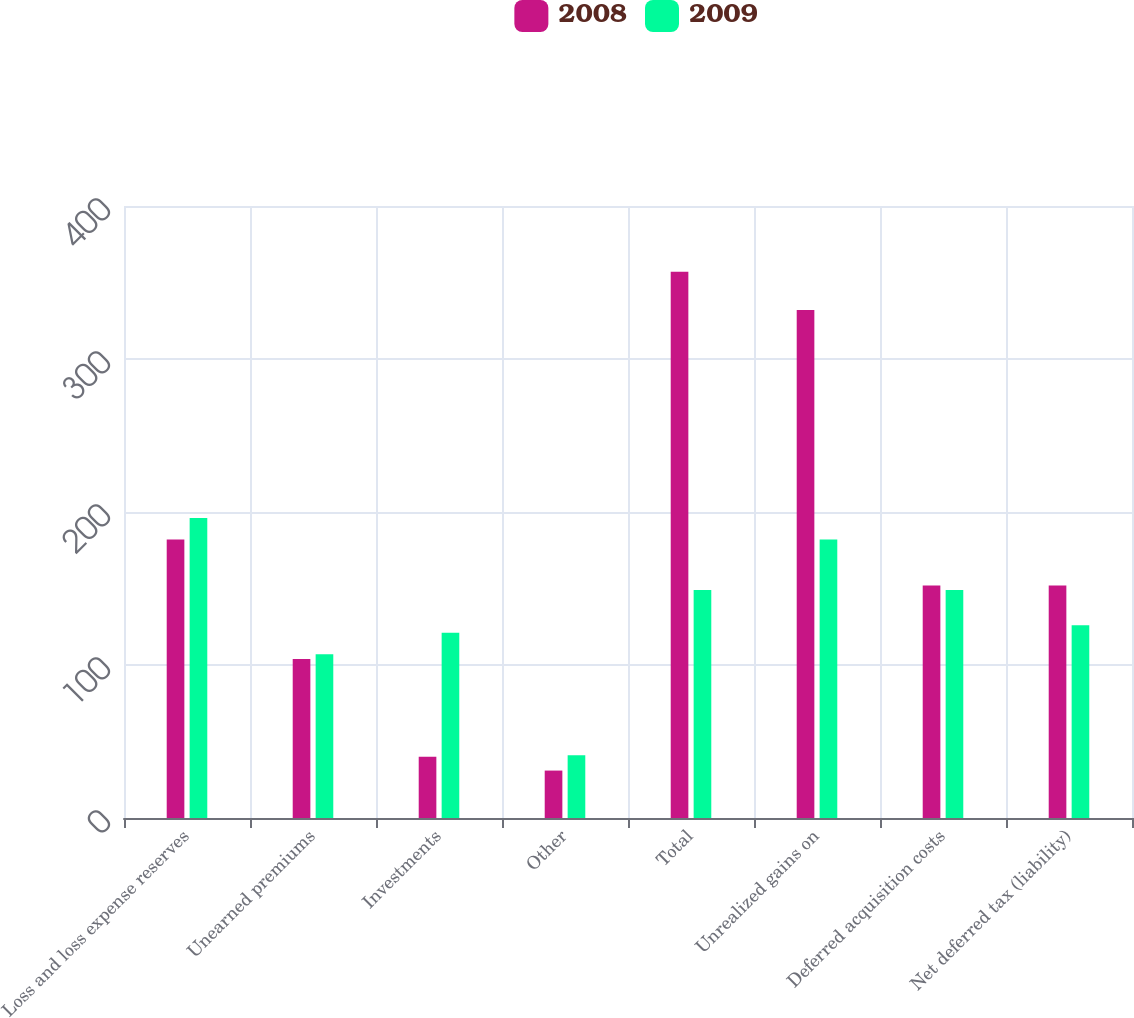Convert chart to OTSL. <chart><loc_0><loc_0><loc_500><loc_500><stacked_bar_chart><ecel><fcel>Loss and loss expense reserves<fcel>Unearned premiums<fcel>Investments<fcel>Other<fcel>Total<fcel>Unrealized gains on<fcel>Deferred acquisition costs<fcel>Net deferred tax (liability)<nl><fcel>2008<fcel>182<fcel>104<fcel>40<fcel>31<fcel>357<fcel>332<fcel>152<fcel>152<nl><fcel>2009<fcel>196<fcel>107<fcel>121<fcel>41<fcel>149<fcel>182<fcel>149<fcel>126<nl></chart> 